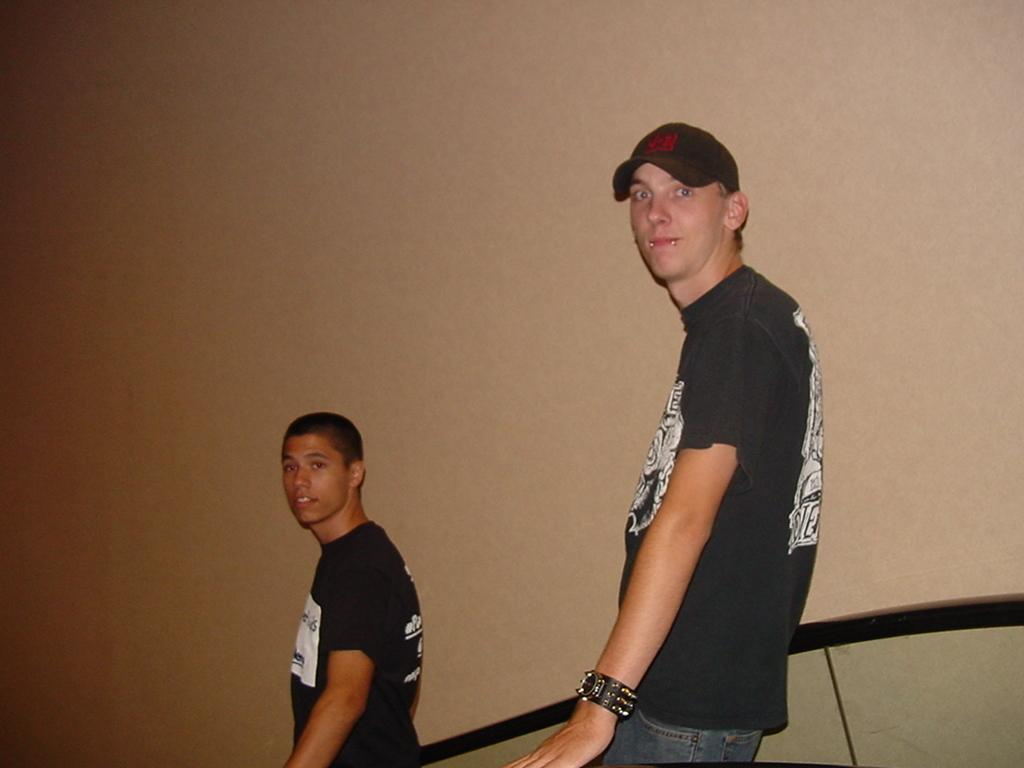Where was the image taken? The image is taken indoors. What can be seen in the background of the image? There is a wall in the background of the image. What are the two men in the image doing? The two men are standing on an escalator in the middle of the image. What type of vegetable is being used as a limit on the escalator in the image? There is no vegetable being used as a limit on the escalator in the image. The escalator is functioning as usual without any vegetable barriers. 